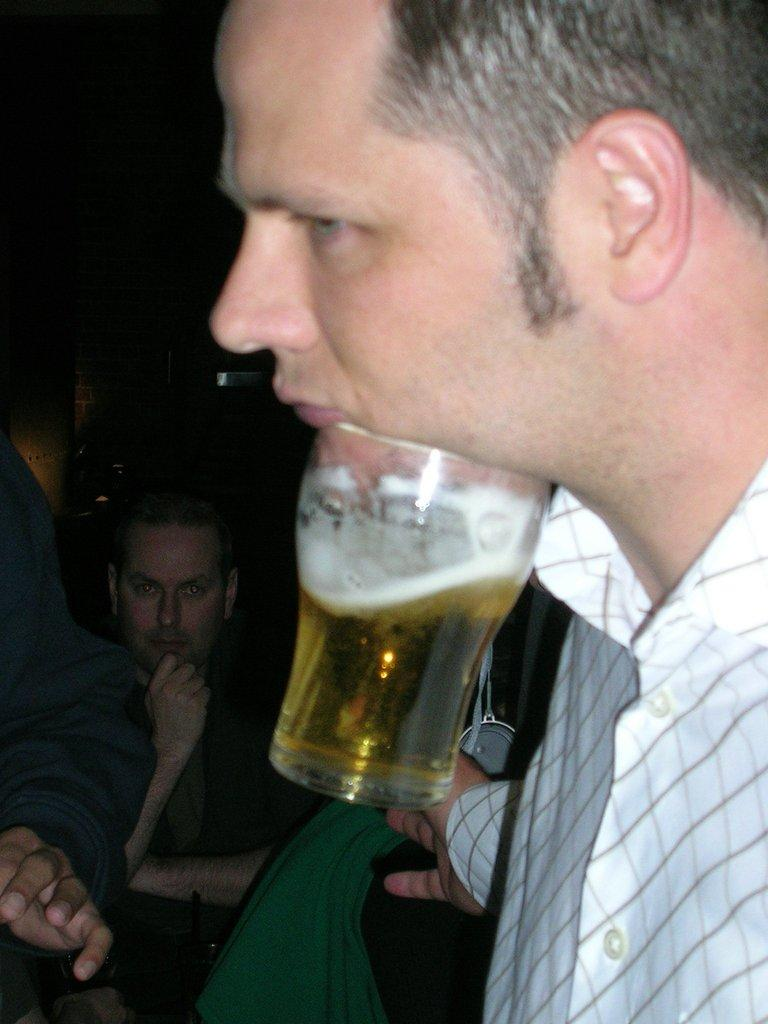How many people are in the image? There are two men in the image. What is present in the image besides the two men? There is a glass with a drink in the image. Where is the calendar located in the image? There is no calendar present in the image. What type of spoon is being used by the men in the image? There is no spoon visible in the image. 